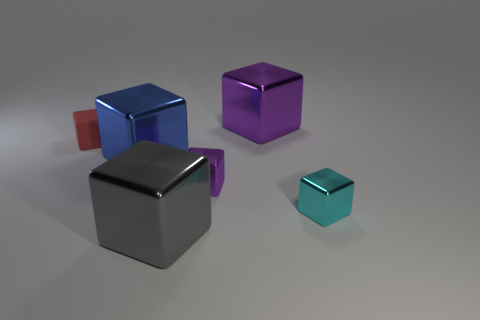Subtract all purple cubes. How many cubes are left? 4 Subtract all large purple blocks. How many blocks are left? 5 Subtract 3 cubes. How many cubes are left? 3 Subtract all green blocks. Subtract all purple balls. How many blocks are left? 6 Add 2 cyan shiny objects. How many objects exist? 8 Subtract all big purple cubes. Subtract all tiny purple shiny objects. How many objects are left? 4 Add 5 tiny purple shiny cubes. How many tiny purple shiny cubes are left? 6 Add 5 large brown cubes. How many large brown cubes exist? 5 Subtract 2 purple cubes. How many objects are left? 4 